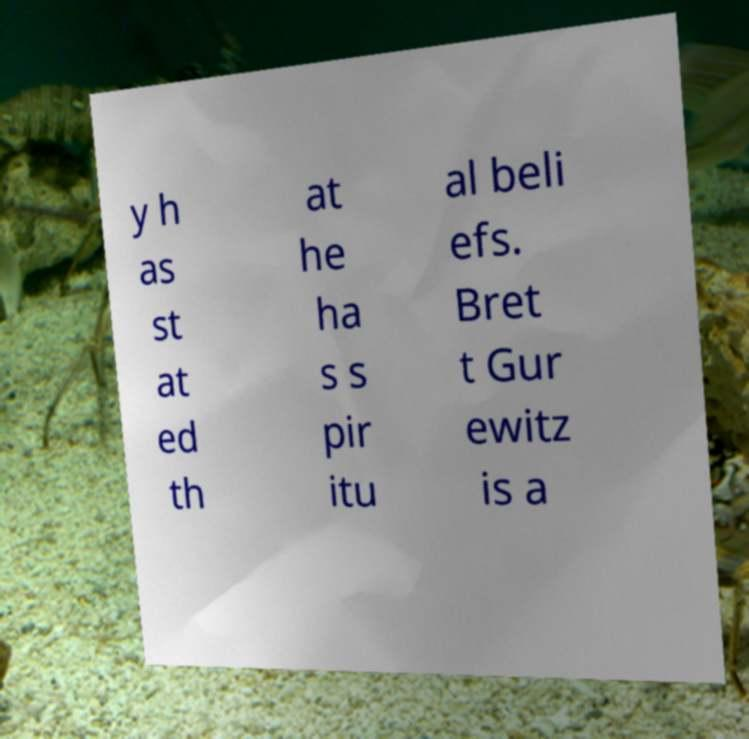Please identify and transcribe the text found in this image. y h as st at ed th at he ha s s pir itu al beli efs. Bret t Gur ewitz is a 